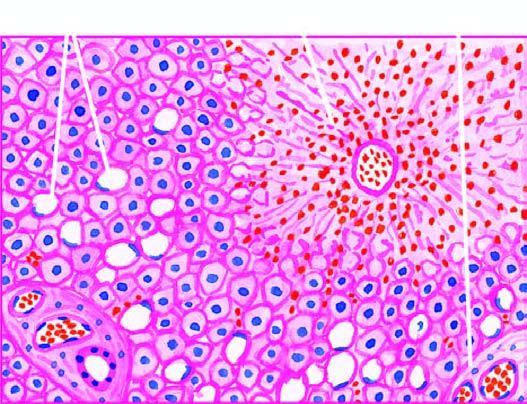does the centrilobular zone show marked degeneration and necrosis of hepatocytes accompanied by haemorrhage while the peripheral zone shows mild fatty change of liver cells?
Answer the question using a single word or phrase. Yes 